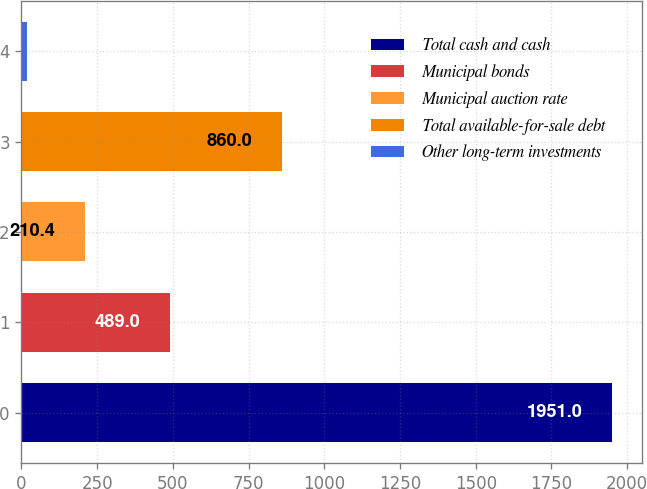<chart> <loc_0><loc_0><loc_500><loc_500><bar_chart><fcel>Total cash and cash<fcel>Municipal bonds<fcel>Municipal auction rate<fcel>Total available-for-sale debt<fcel>Other long-term investments<nl><fcel>1951<fcel>489<fcel>210.4<fcel>860<fcel>17<nl></chart> 